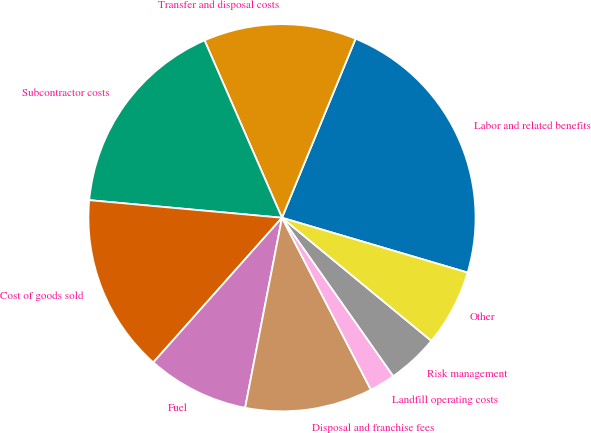<chart> <loc_0><loc_0><loc_500><loc_500><pie_chart><fcel>Labor and related benefits<fcel>Transfer and disposal costs<fcel>Subcontractor costs<fcel>Cost of goods sold<fcel>Fuel<fcel>Disposal and franchise fees<fcel>Landfill operating costs<fcel>Risk management<fcel>Other<nl><fcel>23.36%<fcel>12.76%<fcel>17.0%<fcel>14.88%<fcel>8.52%<fcel>10.64%<fcel>2.16%<fcel>4.28%<fcel>6.4%<nl></chart> 